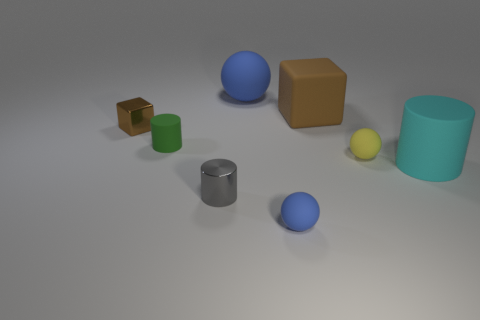How might the different sizes of the objects in the image relate to one another? The varying sizes of the objects might represent a conceptual scale or could be indicative of a visual hierarchy, with larger objects demanding more attention or perhaps signifying greater importance. 